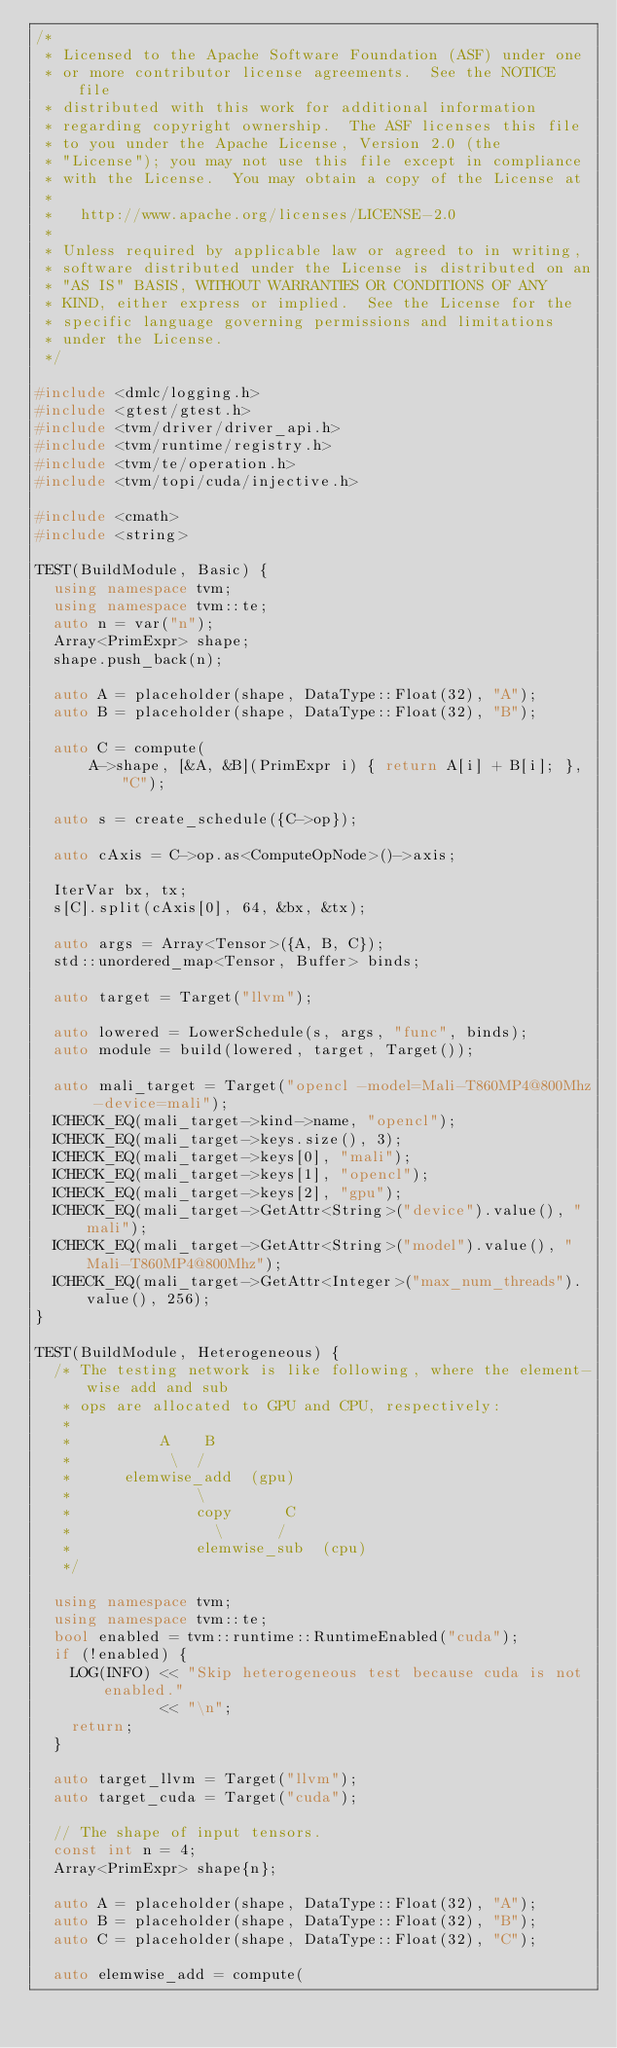Convert code to text. <code><loc_0><loc_0><loc_500><loc_500><_C++_>/*
 * Licensed to the Apache Software Foundation (ASF) under one
 * or more contributor license agreements.  See the NOTICE file
 * distributed with this work for additional information
 * regarding copyright ownership.  The ASF licenses this file
 * to you under the Apache License, Version 2.0 (the
 * "License"); you may not use this file except in compliance
 * with the License.  You may obtain a copy of the License at
 *
 *   http://www.apache.org/licenses/LICENSE-2.0
 *
 * Unless required by applicable law or agreed to in writing,
 * software distributed under the License is distributed on an
 * "AS IS" BASIS, WITHOUT WARRANTIES OR CONDITIONS OF ANY
 * KIND, either express or implied.  See the License for the
 * specific language governing permissions and limitations
 * under the License.
 */

#include <dmlc/logging.h>
#include <gtest/gtest.h>
#include <tvm/driver/driver_api.h>
#include <tvm/runtime/registry.h>
#include <tvm/te/operation.h>
#include <tvm/topi/cuda/injective.h>

#include <cmath>
#include <string>

TEST(BuildModule, Basic) {
  using namespace tvm;
  using namespace tvm::te;
  auto n = var("n");
  Array<PrimExpr> shape;
  shape.push_back(n);

  auto A = placeholder(shape, DataType::Float(32), "A");
  auto B = placeholder(shape, DataType::Float(32), "B");

  auto C = compute(
      A->shape, [&A, &B](PrimExpr i) { return A[i] + B[i]; }, "C");

  auto s = create_schedule({C->op});

  auto cAxis = C->op.as<ComputeOpNode>()->axis;

  IterVar bx, tx;
  s[C].split(cAxis[0], 64, &bx, &tx);

  auto args = Array<Tensor>({A, B, C});
  std::unordered_map<Tensor, Buffer> binds;

  auto target = Target("llvm");

  auto lowered = LowerSchedule(s, args, "func", binds);
  auto module = build(lowered, target, Target());

  auto mali_target = Target("opencl -model=Mali-T860MP4@800Mhz -device=mali");
  ICHECK_EQ(mali_target->kind->name, "opencl");
  ICHECK_EQ(mali_target->keys.size(), 3);
  ICHECK_EQ(mali_target->keys[0], "mali");
  ICHECK_EQ(mali_target->keys[1], "opencl");
  ICHECK_EQ(mali_target->keys[2], "gpu");
  ICHECK_EQ(mali_target->GetAttr<String>("device").value(), "mali");
  ICHECK_EQ(mali_target->GetAttr<String>("model").value(), "Mali-T860MP4@800Mhz");
  ICHECK_EQ(mali_target->GetAttr<Integer>("max_num_threads").value(), 256);
}

TEST(BuildModule, Heterogeneous) {
  /* The testing network is like following, where the element-wise add and sub
   * ops are allocated to GPU and CPU, respectively:
   *
   *          A    B
   *           \  /
   *      elemwise_add  (gpu)
   *              \
   *              copy      C
   *                \      /
   *              elemwise_sub  (cpu)
   */

  using namespace tvm;
  using namespace tvm::te;
  bool enabled = tvm::runtime::RuntimeEnabled("cuda");
  if (!enabled) {
    LOG(INFO) << "Skip heterogeneous test because cuda is not enabled."
              << "\n";
    return;
  }

  auto target_llvm = Target("llvm");
  auto target_cuda = Target("cuda");

  // The shape of input tensors.
  const int n = 4;
  Array<PrimExpr> shape{n};

  auto A = placeholder(shape, DataType::Float(32), "A");
  auto B = placeholder(shape, DataType::Float(32), "B");
  auto C = placeholder(shape, DataType::Float(32), "C");

  auto elemwise_add = compute(</code> 